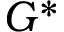Convert formula to latex. <formula><loc_0><loc_0><loc_500><loc_500>G ^ { * }</formula> 